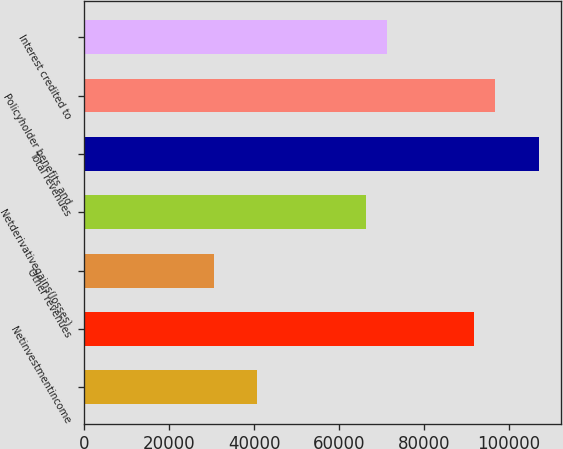Convert chart. <chart><loc_0><loc_0><loc_500><loc_500><bar_chart><ecel><fcel>Netinvestmentincome<fcel>Other revenues<fcel>Netderivativegains(losses)<fcel>Total revenues<fcel>Policyholder benefits and<fcel>Interest credited to<nl><fcel>40799.4<fcel>91712.4<fcel>30616.8<fcel>66255.9<fcel>106986<fcel>96803.7<fcel>71347.2<nl></chart> 